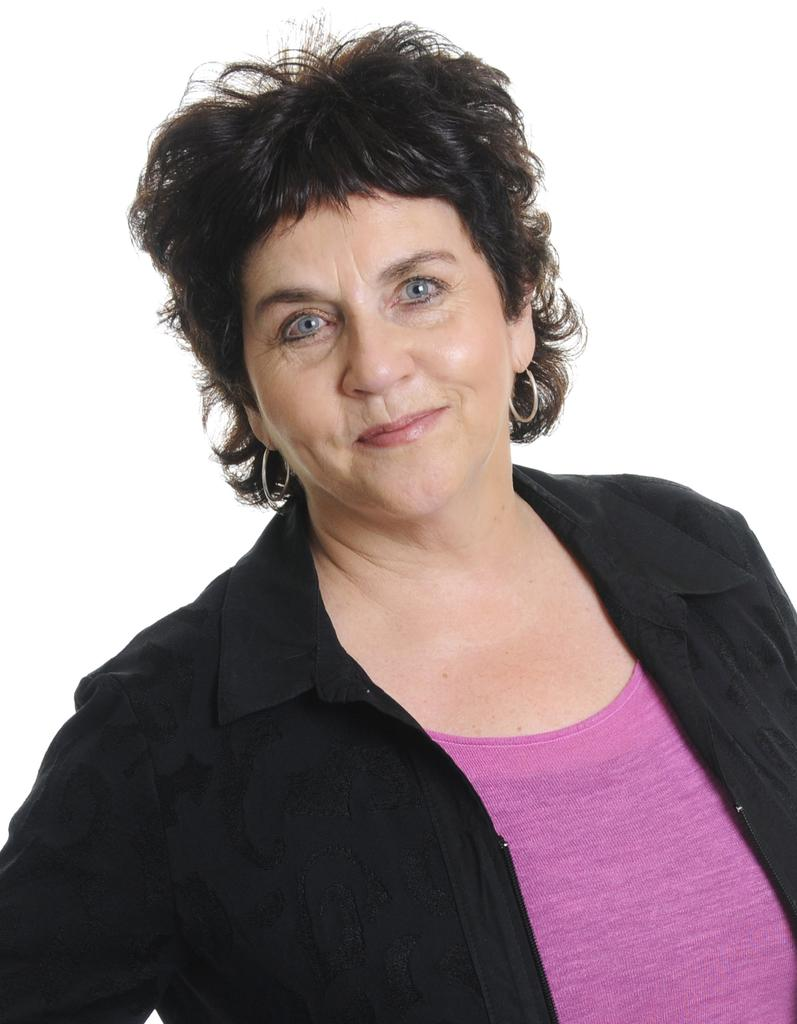Who is present in the image? There is a woman in the image. What is the woman wearing? The woman is wearing a pink and white colored dress. What expression does the woman have? The woman is smiling. What color is the background of the image? The background of the image is white. What type of chess piece is the woman holding in the image? There is no chess piece present in the image. What material is the pen made of that the woman is using to write in the image? There is no pen or writing activity depicted in the image. 